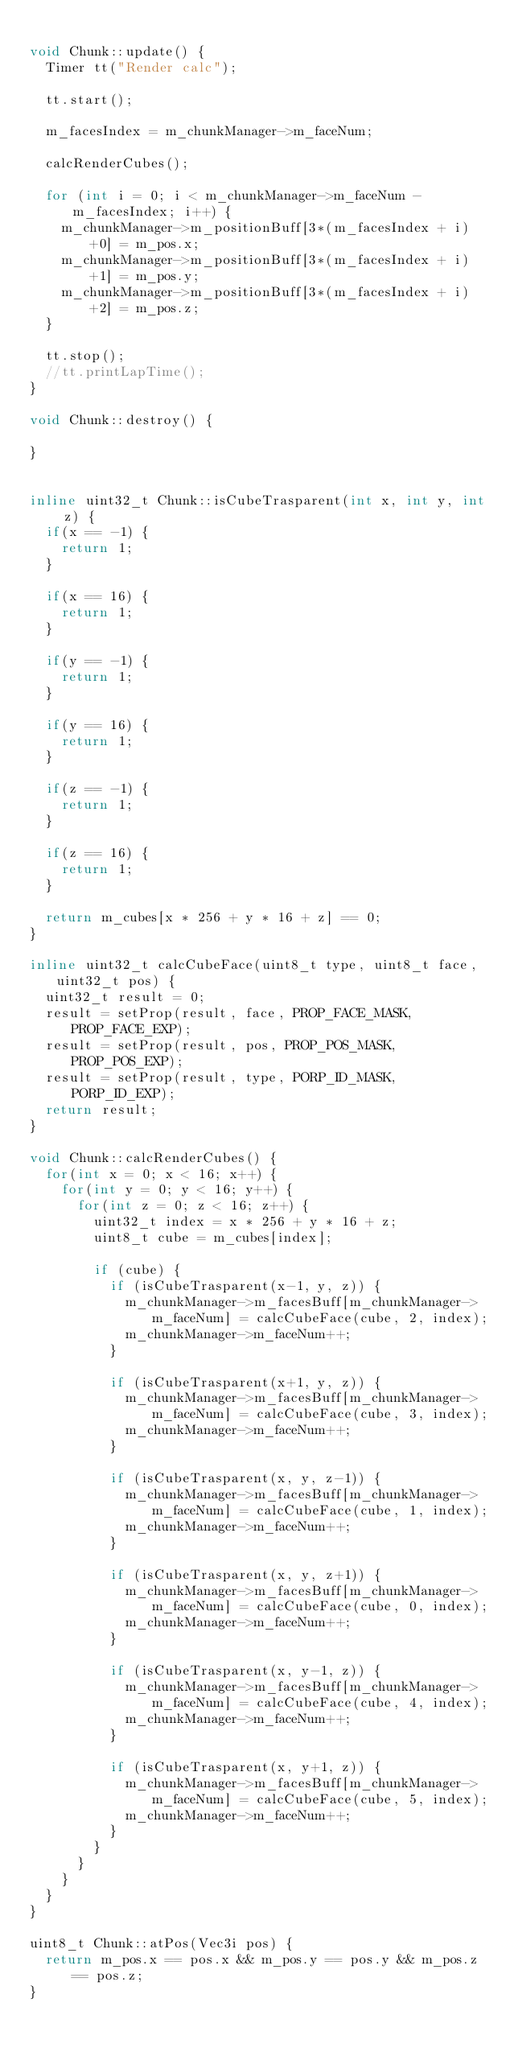Convert code to text. <code><loc_0><loc_0><loc_500><loc_500><_C++_>
void Chunk::update() {
	Timer tt("Render calc");
	
	tt.start();
	
	m_facesIndex = m_chunkManager->m_faceNum;
	
	calcRenderCubes();
	
	for (int i = 0; i < m_chunkManager->m_faceNum - m_facesIndex; i++) {
		m_chunkManager->m_positionBuff[3*(m_facesIndex + i)+0] = m_pos.x;
		m_chunkManager->m_positionBuff[3*(m_facesIndex + i)+1] = m_pos.y;
		m_chunkManager->m_positionBuff[3*(m_facesIndex + i)+2] = m_pos.z;
	}
	
	tt.stop();
	//tt.printLapTime();
}

void Chunk::destroy() {
	
}


inline uint32_t Chunk::isCubeTrasparent(int x, int y, int z) {
	if(x == -1) {
		return 1;
	}
	
	if(x == 16) {
		return 1;
	}
	
	if(y == -1) {
		return 1;
	}
	
	if(y == 16) {
		return 1;
	}
	
	if(z == -1) {
		return 1;
	}
	
	if(z == 16) {
		return 1;
	}
	
	return m_cubes[x * 256 + y * 16 + z] == 0;
}

inline uint32_t calcCubeFace(uint8_t type, uint8_t face, uint32_t pos) {
	uint32_t result = 0;
	result = setProp(result, face, PROP_FACE_MASK, PROP_FACE_EXP);
	result = setProp(result, pos, PROP_POS_MASK, PROP_POS_EXP);
	result = setProp(result, type, PORP_ID_MASK, PORP_ID_EXP);
	return result;
}

void Chunk::calcRenderCubes() {
	for(int x = 0; x < 16; x++) {
		for(int y = 0; y < 16; y++) {
			for(int z = 0; z < 16; z++) {
				uint32_t index = x * 256 + y * 16 + z;
				uint8_t cube = m_cubes[index];
				
				if (cube) {
					if (isCubeTrasparent(x-1, y, z)) {
						m_chunkManager->m_facesBuff[m_chunkManager->m_faceNum] = calcCubeFace(cube, 2, index);
						m_chunkManager->m_faceNum++;
					}
					
					if (isCubeTrasparent(x+1, y, z)) {
						m_chunkManager->m_facesBuff[m_chunkManager->m_faceNum] = calcCubeFace(cube, 3, index);
						m_chunkManager->m_faceNum++;
					}
					
					if (isCubeTrasparent(x, y, z-1)) {
						m_chunkManager->m_facesBuff[m_chunkManager->m_faceNum] = calcCubeFace(cube, 1, index);
						m_chunkManager->m_faceNum++;
					}
					
					if (isCubeTrasparent(x, y, z+1)) {
						m_chunkManager->m_facesBuff[m_chunkManager->m_faceNum] = calcCubeFace(cube, 0, index);
						m_chunkManager->m_faceNum++;
					}
					
					if (isCubeTrasparent(x, y-1, z)) {
						m_chunkManager->m_facesBuff[m_chunkManager->m_faceNum] = calcCubeFace(cube, 4, index);
						m_chunkManager->m_faceNum++;
					}
					
					if (isCubeTrasparent(x, y+1, z)) {
						m_chunkManager->m_facesBuff[m_chunkManager->m_faceNum] = calcCubeFace(cube, 5, index);
						m_chunkManager->m_faceNum++;
					}
				}
			}
		}
	}
}

uint8_t Chunk::atPos(Vec3i pos) {
	return m_pos.x == pos.x && m_pos.y == pos.y && m_pos.z == pos.z;
}
</code> 